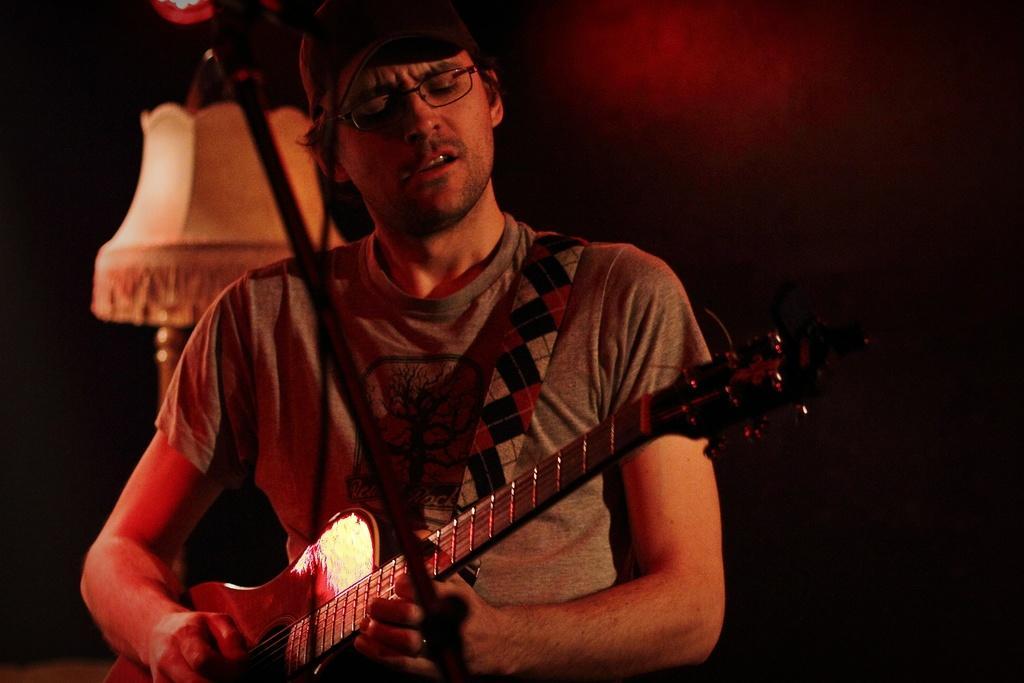How would you summarize this image in a sentence or two? In this picture I can see in the middle a man is playing the guitar, he is wearing a t-shirt and the spectacles. 